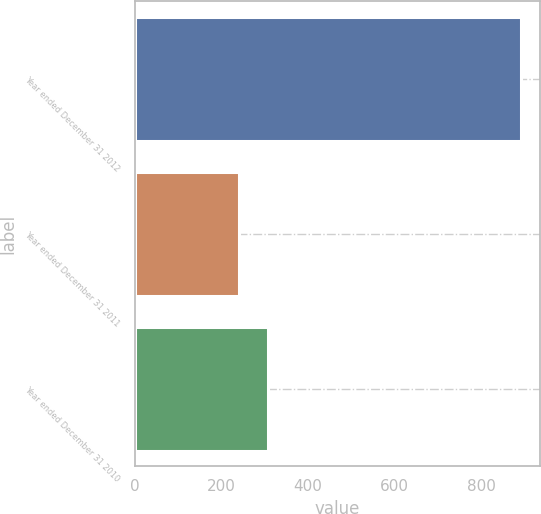Convert chart. <chart><loc_0><loc_0><loc_500><loc_500><bar_chart><fcel>Year ended December 31 2012<fcel>Year ended December 31 2011<fcel>Year ended December 31 2010<nl><fcel>891<fcel>242<fcel>306.9<nl></chart> 